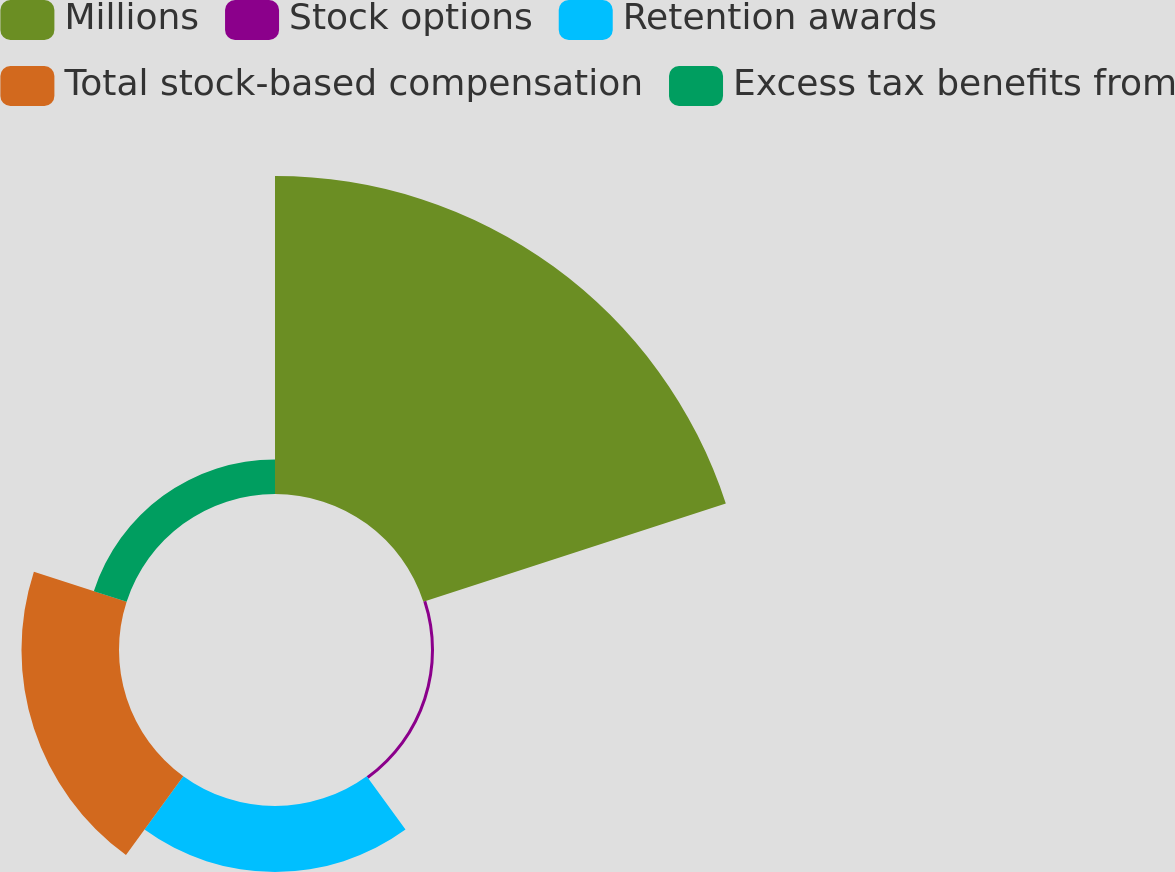Convert chart. <chart><loc_0><loc_0><loc_500><loc_500><pie_chart><fcel>Millions<fcel>Stock options<fcel>Retention awards<fcel>Total stock-based compensation<fcel>Excess tax benefits from<nl><fcel>61.27%<fcel>0.58%<fcel>12.72%<fcel>18.79%<fcel>6.65%<nl></chart> 